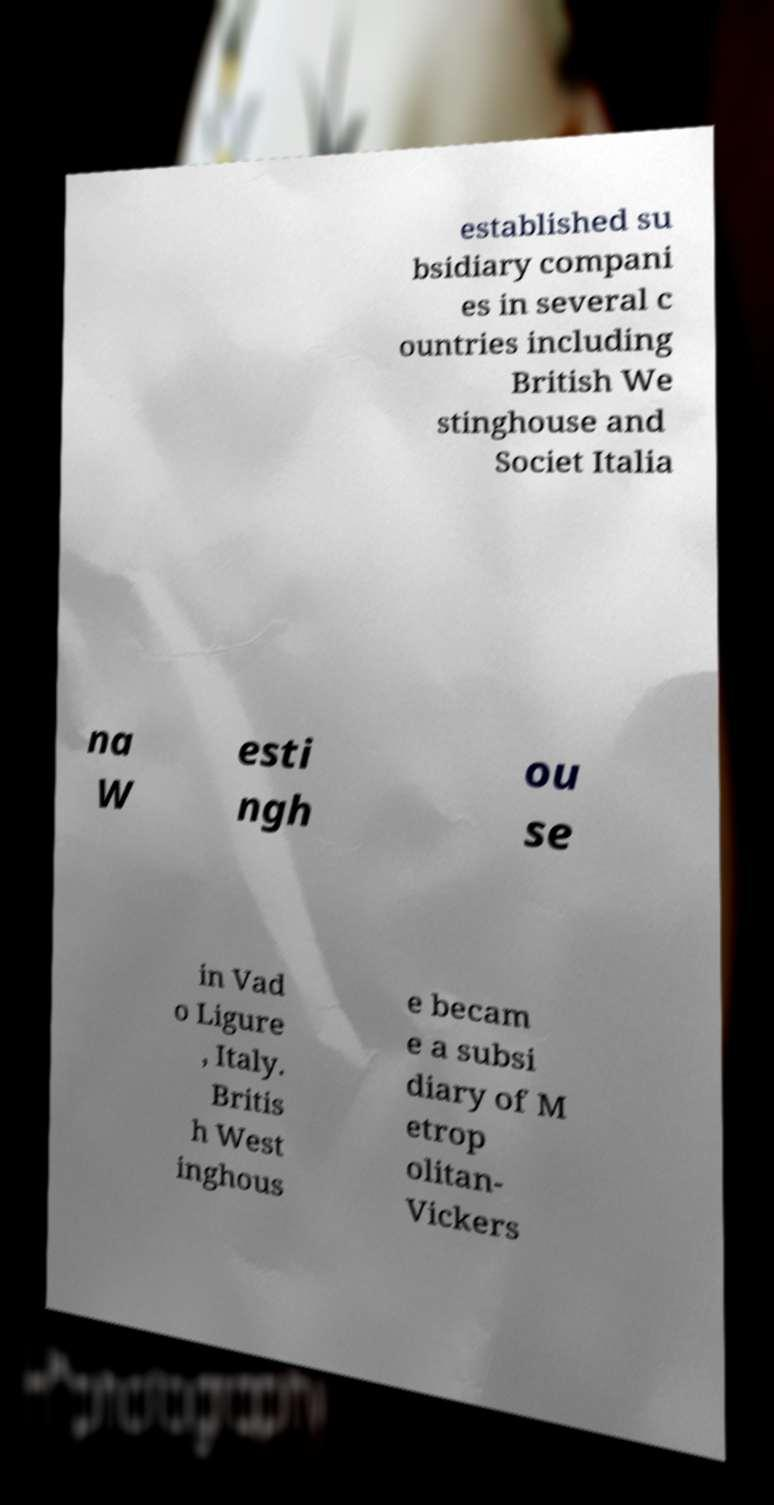What messages or text are displayed in this image? I need them in a readable, typed format. established su bsidiary compani es in several c ountries including British We stinghouse and Societ Italia na W esti ngh ou se in Vad o Ligure , Italy. Britis h West inghous e becam e a subsi diary of M etrop olitan- Vickers 